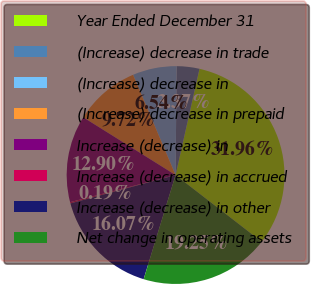<chart> <loc_0><loc_0><loc_500><loc_500><pie_chart><fcel>Year Ended December 31<fcel>(Increase) decrease in trade<fcel>(Increase) decrease in<fcel>(Increase) decrease in prepaid<fcel>Increase (decrease) in<fcel>Increase (decrease) in accrued<fcel>Increase (decrease) in other<fcel>Net change in operating assets<nl><fcel>31.96%<fcel>3.37%<fcel>6.54%<fcel>9.72%<fcel>12.9%<fcel>0.19%<fcel>16.07%<fcel>19.25%<nl></chart> 